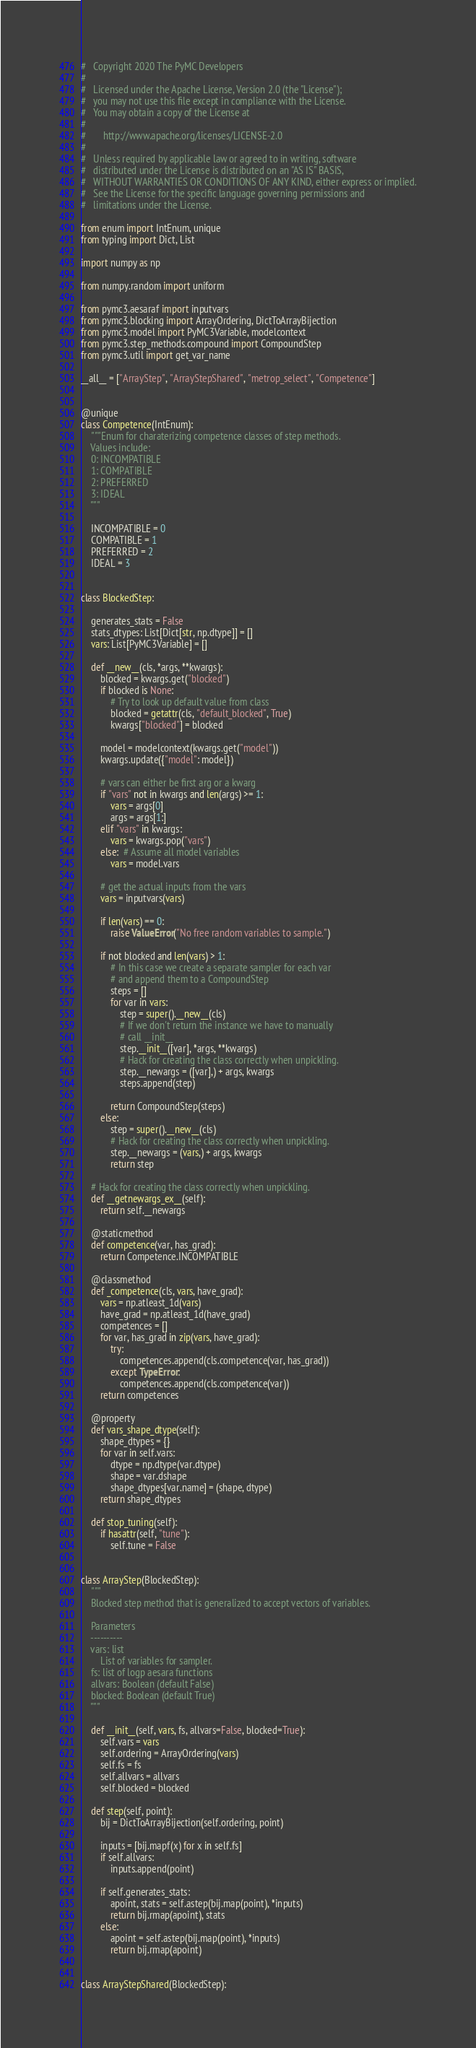<code> <loc_0><loc_0><loc_500><loc_500><_Python_>#   Copyright 2020 The PyMC Developers
#
#   Licensed under the Apache License, Version 2.0 (the "License");
#   you may not use this file except in compliance with the License.
#   You may obtain a copy of the License at
#
#       http://www.apache.org/licenses/LICENSE-2.0
#
#   Unless required by applicable law or agreed to in writing, software
#   distributed under the License is distributed on an "AS IS" BASIS,
#   WITHOUT WARRANTIES OR CONDITIONS OF ANY KIND, either express or implied.
#   See the License for the specific language governing permissions and
#   limitations under the License.

from enum import IntEnum, unique
from typing import Dict, List

import numpy as np

from numpy.random import uniform

from pymc3.aesaraf import inputvars
from pymc3.blocking import ArrayOrdering, DictToArrayBijection
from pymc3.model import PyMC3Variable, modelcontext
from pymc3.step_methods.compound import CompoundStep
from pymc3.util import get_var_name

__all__ = ["ArrayStep", "ArrayStepShared", "metrop_select", "Competence"]


@unique
class Competence(IntEnum):
    """Enum for charaterizing competence classes of step methods.
    Values include:
    0: INCOMPATIBLE
    1: COMPATIBLE
    2: PREFERRED
    3: IDEAL
    """

    INCOMPATIBLE = 0
    COMPATIBLE = 1
    PREFERRED = 2
    IDEAL = 3


class BlockedStep:

    generates_stats = False
    stats_dtypes: List[Dict[str, np.dtype]] = []
    vars: List[PyMC3Variable] = []

    def __new__(cls, *args, **kwargs):
        blocked = kwargs.get("blocked")
        if blocked is None:
            # Try to look up default value from class
            blocked = getattr(cls, "default_blocked", True)
            kwargs["blocked"] = blocked

        model = modelcontext(kwargs.get("model"))
        kwargs.update({"model": model})

        # vars can either be first arg or a kwarg
        if "vars" not in kwargs and len(args) >= 1:
            vars = args[0]
            args = args[1:]
        elif "vars" in kwargs:
            vars = kwargs.pop("vars")
        else:  # Assume all model variables
            vars = model.vars

        # get the actual inputs from the vars
        vars = inputvars(vars)

        if len(vars) == 0:
            raise ValueError("No free random variables to sample.")

        if not blocked and len(vars) > 1:
            # In this case we create a separate sampler for each var
            # and append them to a CompoundStep
            steps = []
            for var in vars:
                step = super().__new__(cls)
                # If we don't return the instance we have to manually
                # call __init__
                step.__init__([var], *args, **kwargs)
                # Hack for creating the class correctly when unpickling.
                step.__newargs = ([var],) + args, kwargs
                steps.append(step)

            return CompoundStep(steps)
        else:
            step = super().__new__(cls)
            # Hack for creating the class correctly when unpickling.
            step.__newargs = (vars,) + args, kwargs
            return step

    # Hack for creating the class correctly when unpickling.
    def __getnewargs_ex__(self):
        return self.__newargs

    @staticmethod
    def competence(var, has_grad):
        return Competence.INCOMPATIBLE

    @classmethod
    def _competence(cls, vars, have_grad):
        vars = np.atleast_1d(vars)
        have_grad = np.atleast_1d(have_grad)
        competences = []
        for var, has_grad in zip(vars, have_grad):
            try:
                competences.append(cls.competence(var, has_grad))
            except TypeError:
                competences.append(cls.competence(var))
        return competences

    @property
    def vars_shape_dtype(self):
        shape_dtypes = {}
        for var in self.vars:
            dtype = np.dtype(var.dtype)
            shape = var.dshape
            shape_dtypes[var.name] = (shape, dtype)
        return shape_dtypes

    def stop_tuning(self):
        if hasattr(self, "tune"):
            self.tune = False


class ArrayStep(BlockedStep):
    """
    Blocked step method that is generalized to accept vectors of variables.

    Parameters
    ----------
    vars: list
        List of variables for sampler.
    fs: list of logp aesara functions
    allvars: Boolean (default False)
    blocked: Boolean (default True)
    """

    def __init__(self, vars, fs, allvars=False, blocked=True):
        self.vars = vars
        self.ordering = ArrayOrdering(vars)
        self.fs = fs
        self.allvars = allvars
        self.blocked = blocked

    def step(self, point):
        bij = DictToArrayBijection(self.ordering, point)

        inputs = [bij.mapf(x) for x in self.fs]
        if self.allvars:
            inputs.append(point)

        if self.generates_stats:
            apoint, stats = self.astep(bij.map(point), *inputs)
            return bij.rmap(apoint), stats
        else:
            apoint = self.astep(bij.map(point), *inputs)
            return bij.rmap(apoint)


class ArrayStepShared(BlockedStep):</code> 